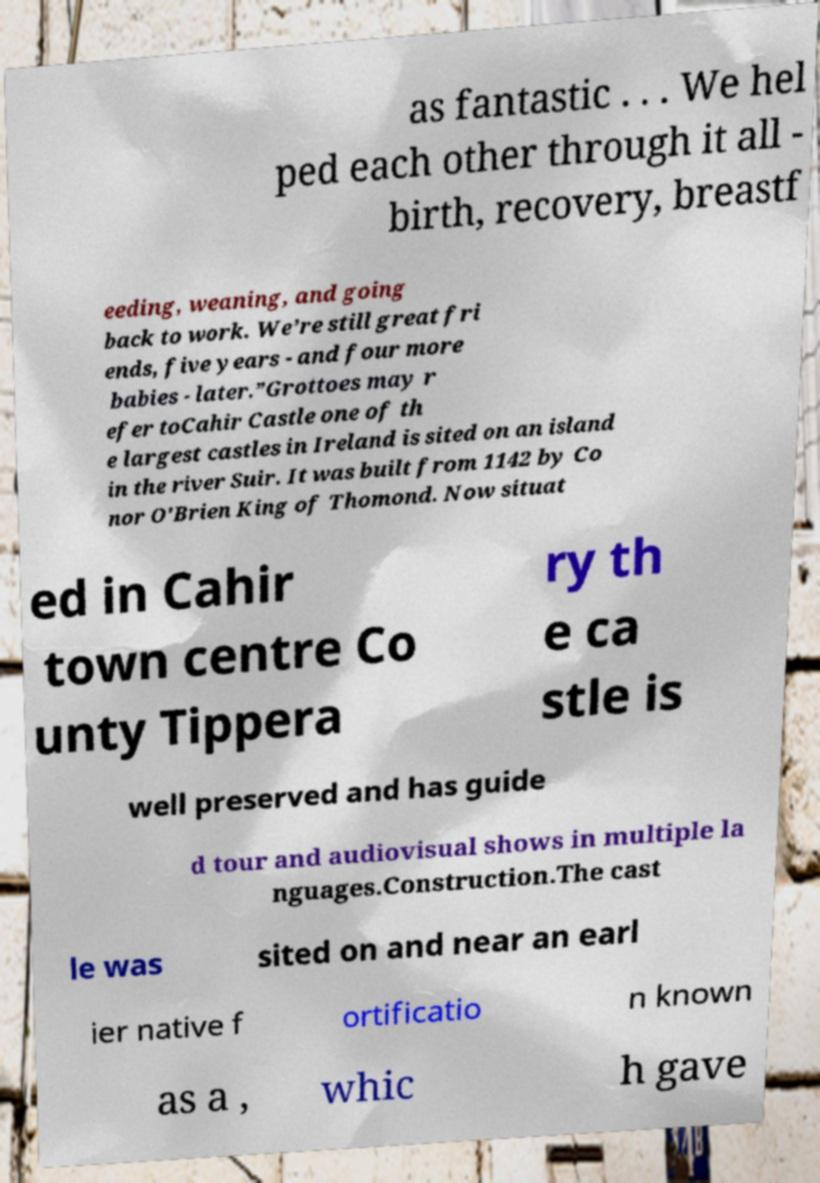Could you extract and type out the text from this image? as fantastic . . . We hel ped each other through it all - birth, recovery, breastf eeding, weaning, and going back to work. We’re still great fri ends, five years - and four more babies - later.”Grottoes may r efer toCahir Castle one of th e largest castles in Ireland is sited on an island in the river Suir. It was built from 1142 by Co nor O'Brien King of Thomond. Now situat ed in Cahir town centre Co unty Tippera ry th e ca stle is well preserved and has guide d tour and audiovisual shows in multiple la nguages.Construction.The cast le was sited on and near an earl ier native f ortificatio n known as a , whic h gave 